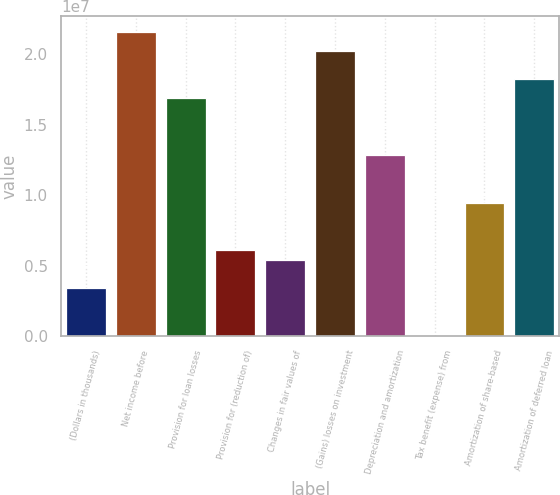Convert chart to OTSL. <chart><loc_0><loc_0><loc_500><loc_500><bar_chart><fcel>(Dollars in thousands)<fcel>Net income before<fcel>Provision for loan losses<fcel>Provision for (reduction of)<fcel>Changes in fair values of<fcel>(Gains) losses on investment<fcel>Depreciation and amortization<fcel>Tax benefit (expense) from<fcel>Amortization of share-based<fcel>Amortization of deferred loan<nl><fcel>3.37867e+06<fcel>2.16225e+07<fcel>1.68926e+07<fcel>6.08145e+06<fcel>5.40576e+06<fcel>2.02711e+07<fcel>1.28384e+07<fcel>189<fcel>9.45993e+06<fcel>1.8244e+07<nl></chart> 